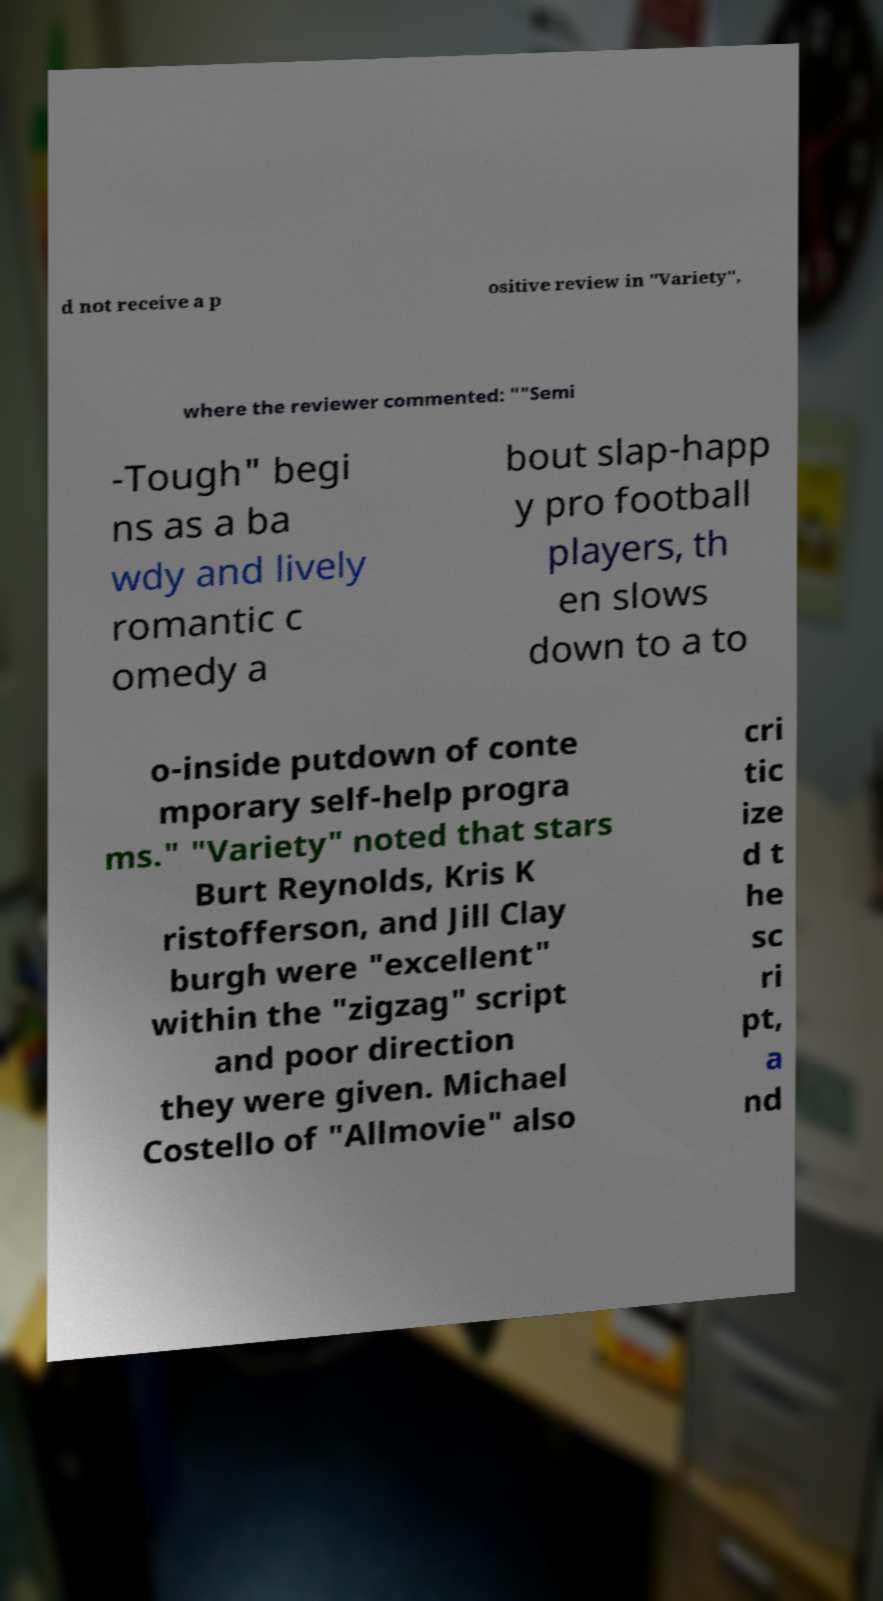Please read and relay the text visible in this image. What does it say? d not receive a p ositive review in "Variety", where the reviewer commented: ""Semi -Tough" begi ns as a ba wdy and lively romantic c omedy a bout slap-happ y pro football players, th en slows down to a to o-inside putdown of conte mporary self-help progra ms." "Variety" noted that stars Burt Reynolds, Kris K ristofferson, and Jill Clay burgh were "excellent" within the "zigzag" script and poor direction they were given. Michael Costello of "Allmovie" also cri tic ize d t he sc ri pt, a nd 